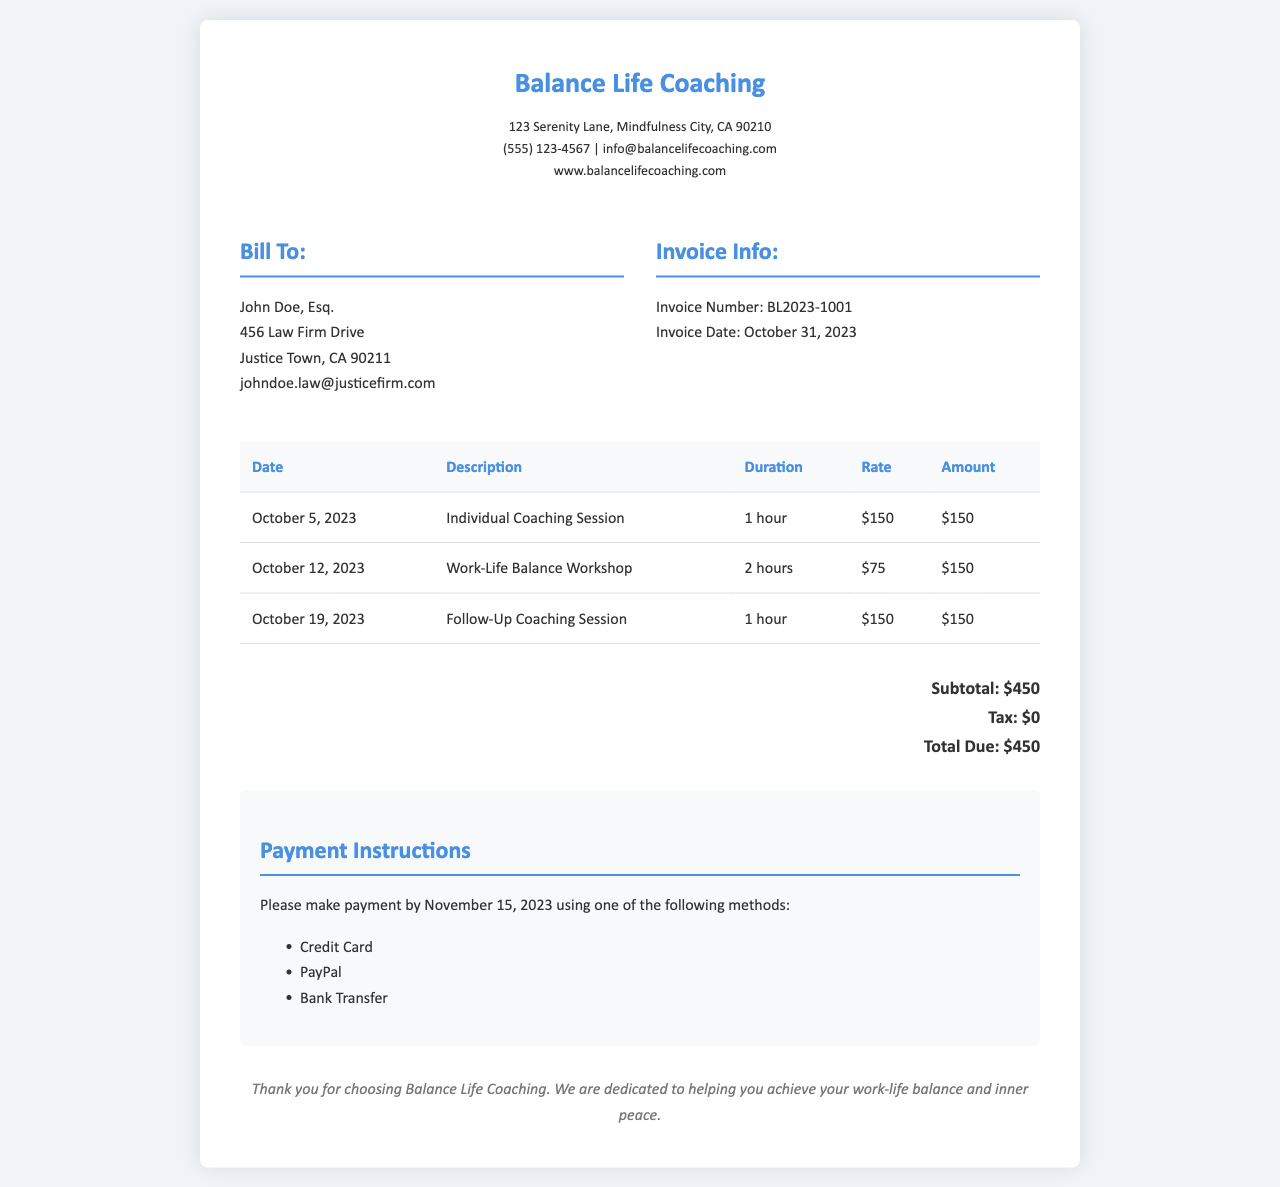What is the invoice number? The invoice number is specifically stated in the document as a unique identifier for this transaction, which is BL2023-1001.
Answer: BL2023-1001 What is the total due amount? The total amount due is clearly stated in the total amount section of the document, which sums all applicable charges, totaling $450.
Answer: $450 How many individual coaching sessions are listed? The document details the services rendered, including the individual coaching sessions, which are specified as two instances (one session and one follow-up).
Answer: 2 What is the hourly rate for an individual coaching session? The document provides clear rates for different services, specifying that the hourly rate for an individual coaching session is $150.
Answer: $150 What payment methods are accepted? The document lists several acceptable payment methods, which include Credit Card, PayPal, and Bank Transfer.
Answer: Credit Card, PayPal, Bank Transfer What date was the work-life balance workshop held? The date of the workshop is explicitly mentioned in the session details, which indicates it took place on October 12, 2023.
Answer: October 12, 2023 How long did the work-life balance workshop last? The document indicates the duration of the workshop, which is specified as 2 hours.
Answer: 2 hours What is the company name? The document begins with the name of the company providing the services, which is Balance Life Coaching.
Answer: Balance Life Coaching What date is the invoice issued? The date of invoice issuance is stated in the invoice details section, which is October 31, 2023.
Answer: October 31, 2023 